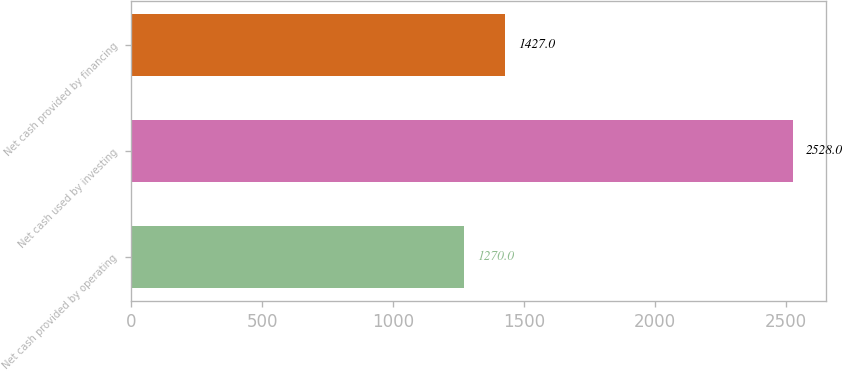Convert chart. <chart><loc_0><loc_0><loc_500><loc_500><bar_chart><fcel>Net cash provided by operating<fcel>Net cash used by investing<fcel>Net cash provided by financing<nl><fcel>1270<fcel>2528<fcel>1427<nl></chart> 